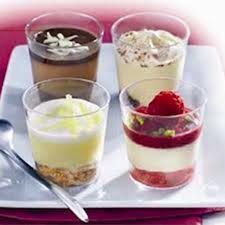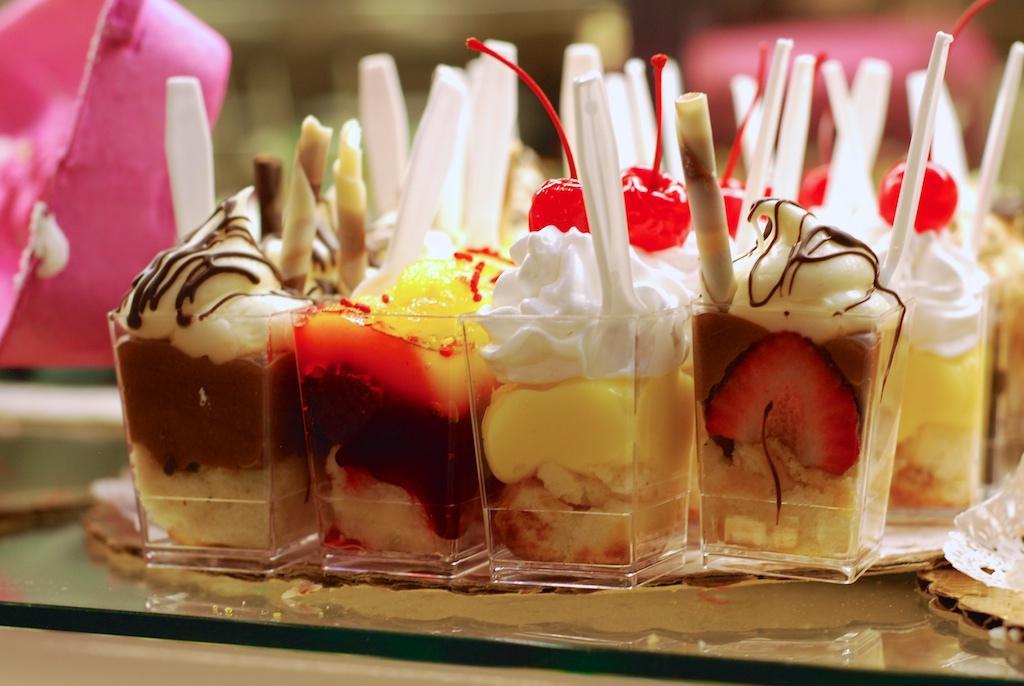The first image is the image on the left, the second image is the image on the right. Assess this claim about the two images: "there are blueberries on the top of the dessert on the right". Correct or not? Answer yes or no. No. The first image is the image on the left, the second image is the image on the right. For the images displayed, is the sentence "There are at least four different recipes in cups." factually correct? Answer yes or no. Yes. 